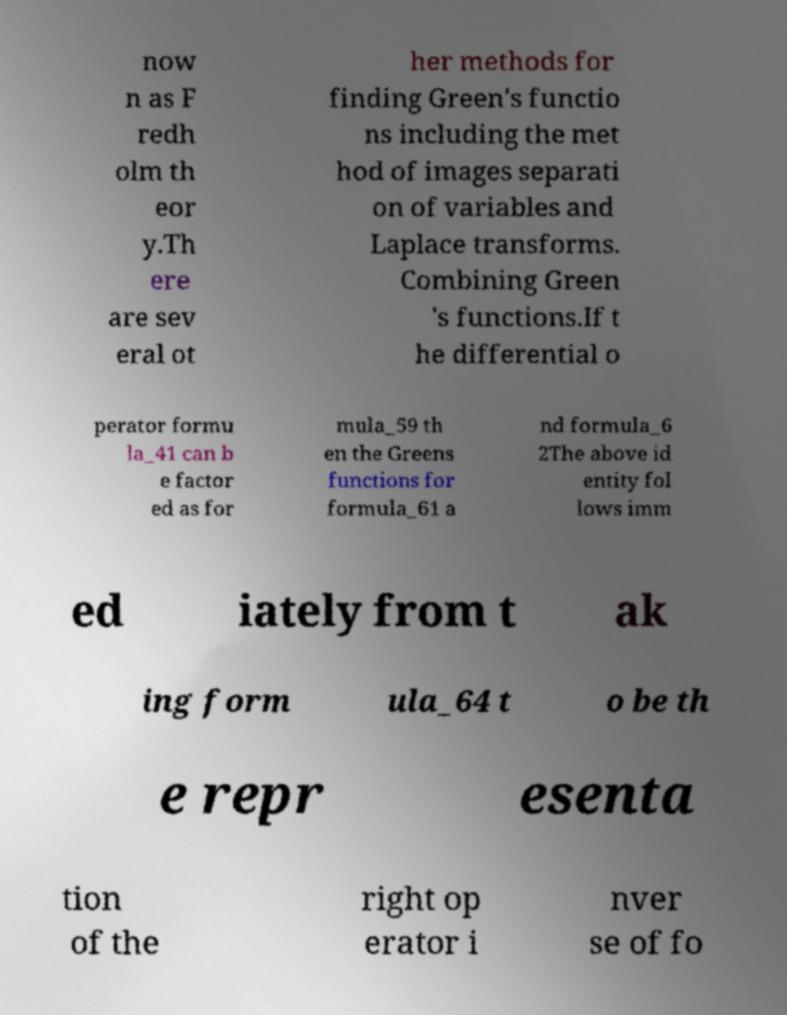Could you assist in decoding the text presented in this image and type it out clearly? now n as F redh olm th eor y.Th ere are sev eral ot her methods for finding Green's functio ns including the met hod of images separati on of variables and Laplace transforms. Combining Green 's functions.If t he differential o perator formu la_41 can b e factor ed as for mula_59 th en the Greens functions for formula_61 a nd formula_6 2The above id entity fol lows imm ed iately from t ak ing form ula_64 t o be th e repr esenta tion of the right op erator i nver se of fo 